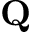Convert formula to latex. <formula><loc_0><loc_0><loc_500><loc_500>Q</formula> 